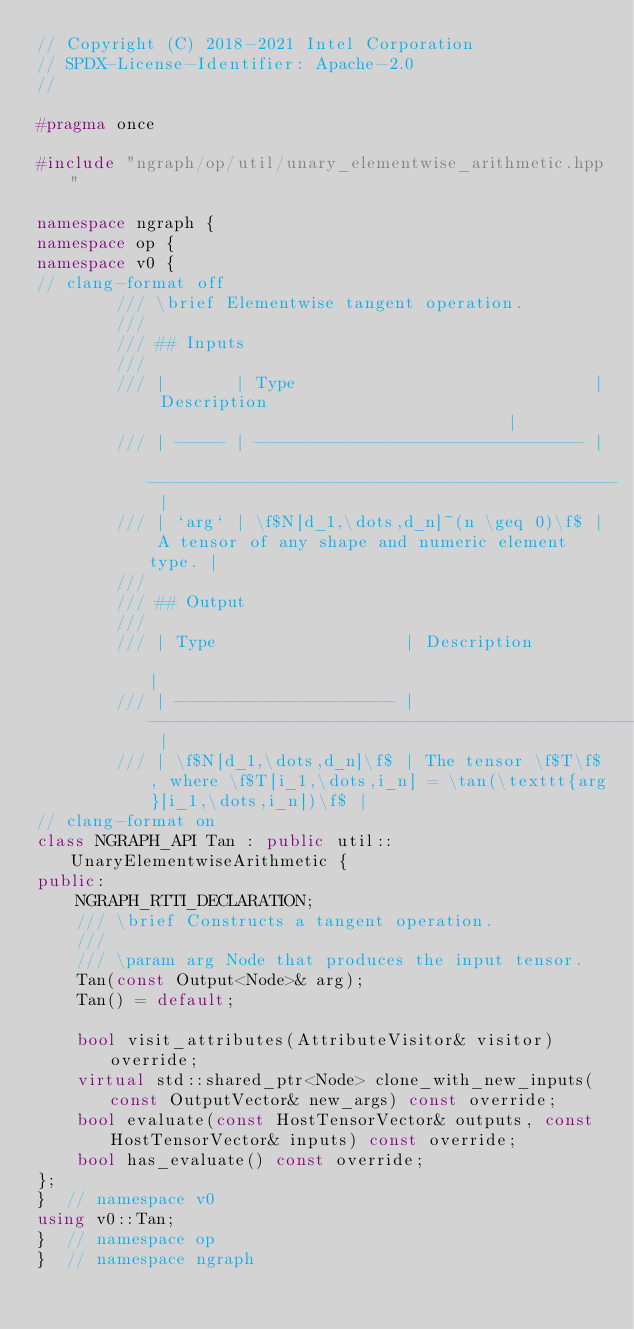<code> <loc_0><loc_0><loc_500><loc_500><_C++_>// Copyright (C) 2018-2021 Intel Corporation
// SPDX-License-Identifier: Apache-2.0
//

#pragma once

#include "ngraph/op/util/unary_elementwise_arithmetic.hpp"

namespace ngraph {
namespace op {
namespace v0 {
// clang-format off
        /// \brief Elementwise tangent operation.
        ///
        /// ## Inputs
        ///
        /// |       | Type                              | Description                                     |
        /// | ----- | --------------------------------- | ----------------------------------------------- |
        /// | `arg` | \f$N[d_1,\dots,d_n]~(n \geq 0)\f$ | A tensor of any shape and numeric element type. |
        ///
        /// ## Output
        ///
        /// | Type                   | Description                                                                          |
        /// | ---------------------- | ------------------------------------------------------------------------------------ |
        /// | \f$N[d_1,\dots,d_n]\f$ | The tensor \f$T\f$, where \f$T[i_1,\dots,i_n] = \tan(\texttt{arg}[i_1,\dots,i_n])\f$ |
// clang-format on
class NGRAPH_API Tan : public util::UnaryElementwiseArithmetic {
public:
    NGRAPH_RTTI_DECLARATION;
    /// \brief Constructs a tangent operation.
    ///
    /// \param arg Node that produces the input tensor.
    Tan(const Output<Node>& arg);
    Tan() = default;

    bool visit_attributes(AttributeVisitor& visitor) override;
    virtual std::shared_ptr<Node> clone_with_new_inputs(const OutputVector& new_args) const override;
    bool evaluate(const HostTensorVector& outputs, const HostTensorVector& inputs) const override;
    bool has_evaluate() const override;
};
}  // namespace v0
using v0::Tan;
}  // namespace op
}  // namespace ngraph
</code> 